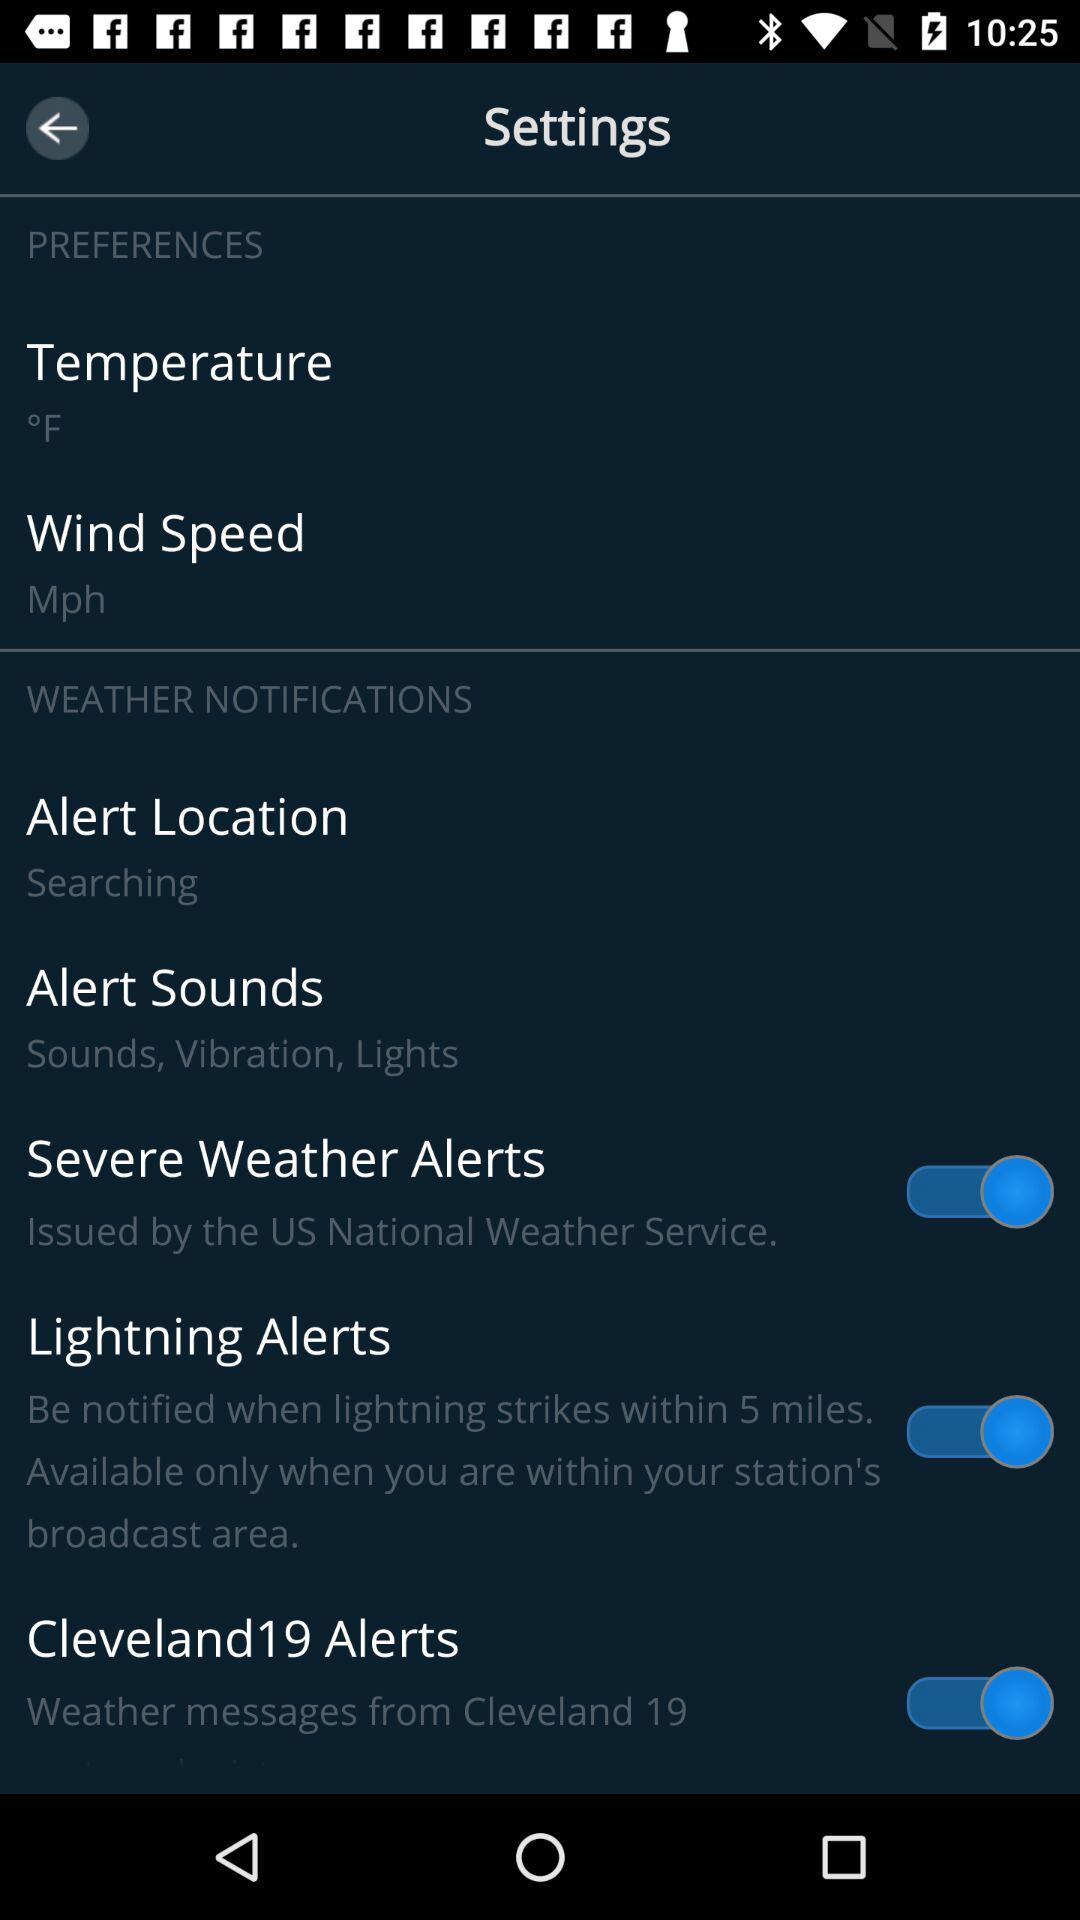What is the status of "Lightning Alerts"? The status of "Lightning Alerts" is "on". 